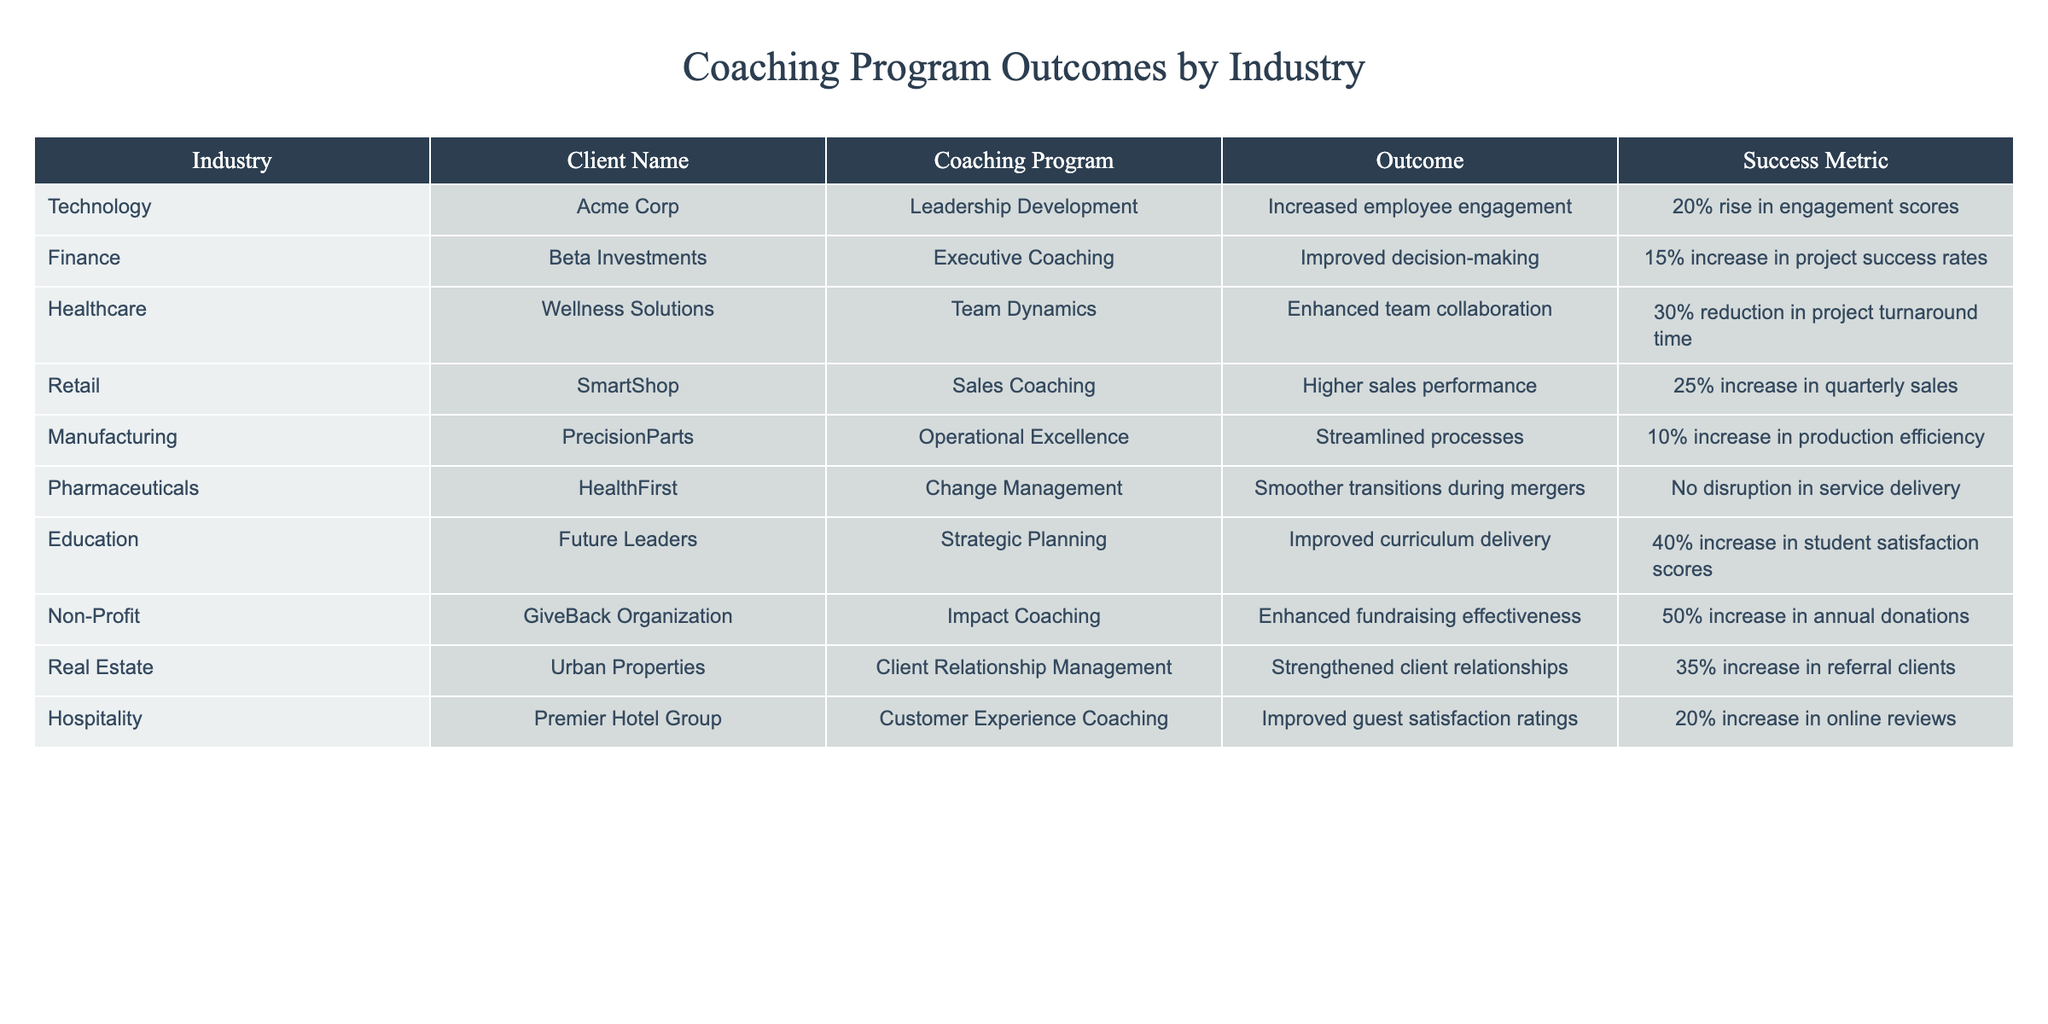What is the outcome of the coaching program for Acme Corp? The table lists the outcome for Acme Corp under the Technology industry, which is "Increased employee engagement."
Answer: Increased employee engagement Which industry saw a 50% increase in annual donations? By examining the table, we find that the Non-Profit industry, represented by GiveBack Organization, achieved a 50% increase in annual donations.
Answer: Non-Profit What is the success metric for Wellness Solutions? The table indicates that the success metric for Wellness Solutions in the Healthcare industry is a "30% reduction in project turnaround time."
Answer: 30% reduction in project turnaround time Which coaching program had the highest success metric? By comparing all the success metrics, the highest is the Impact Coaching for GiveBack Organization, with a 50% increase in annual donations.
Answer: Impact Coaching for GiveBack Organization What is the difference in success metrics between the Education and Finance industries? The success metric for Education (Future Leaders) is a 40% increase in student satisfaction scores, while for Finance (Beta Investments) it is a 15% increase in project success rates. The difference is 40% - 15% = 25%.
Answer: 25% Identify the industry with the lowest success metric and provide its value. Looking through the success metrics, the Manufacturing industry (PrecisionParts) shows the lowest success metric at a "10% increase in production efficiency."
Answer: 10% increase in production efficiency Is it true that all coaching programs in the table resulted in positive outcomes? After reviewing the outcomes, all listed programs resulted in positive outcomes; none indicated a negative result.
Answer: Yes What is the average success metric percentage across all industries listed in the table? We sum the values of each success metric: 20% + 15% + 30% + 25% + 10% + 0% + 40% + 50% + 35% + 20% = 225%. There are 10 data points, so the average is 225% / 10 = 22.5%.
Answer: 22.5% Which coaching program in the Retail industry led to higher sales performance? The table shows that SmartShop underwent a Sales Coaching program, resulting in "25% increase in quarterly sales."
Answer: Sales Coaching at SmartShop How many industries show an increase in their success metrics greater than 20%? By reviewing the table, the industries with success metrics greater than 20% are Healthcare (30%), Retail (25%), Education (40%), Non-Profit (50%), Real Estate (35%), and Hospitality (20%). Thus, there are 6 such industries.
Answer: 6 